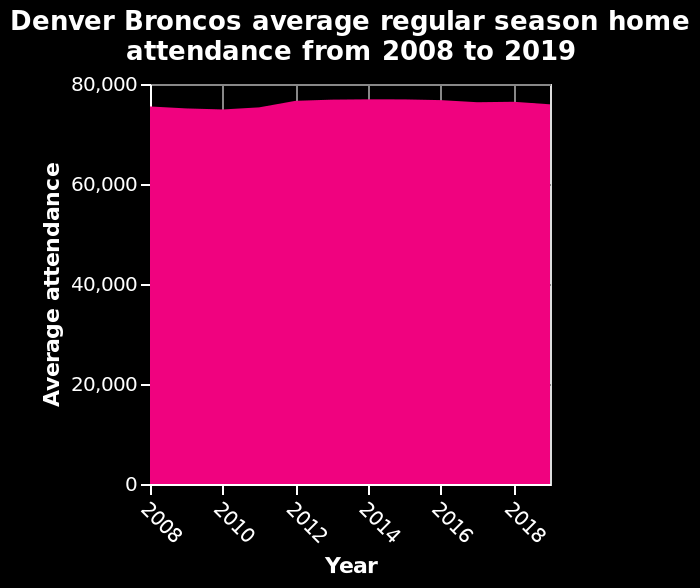<image>
Is the attendance consistent at Denver Broncos games?  Yes, the attendance is consistent at Denver Broncos games. What is the measurement unit used for average attendance? The measurement unit used for average attendance is not specified in the given information. What is the subject of this chart?  The subject of this chart is attendance at Denver Broncos games. Is the data presented in the form of an area chart?  Yes, the data is presented in the form of an area chart. 